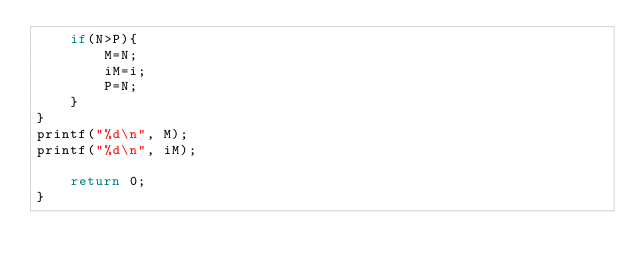<code> <loc_0><loc_0><loc_500><loc_500><_C_>    if(N>P){
        M=N;
        iM=i;
        P=N;
    }
}
printf("%d\n", M);
printf("%d\n", iM);
 
    return 0;
}
</code> 